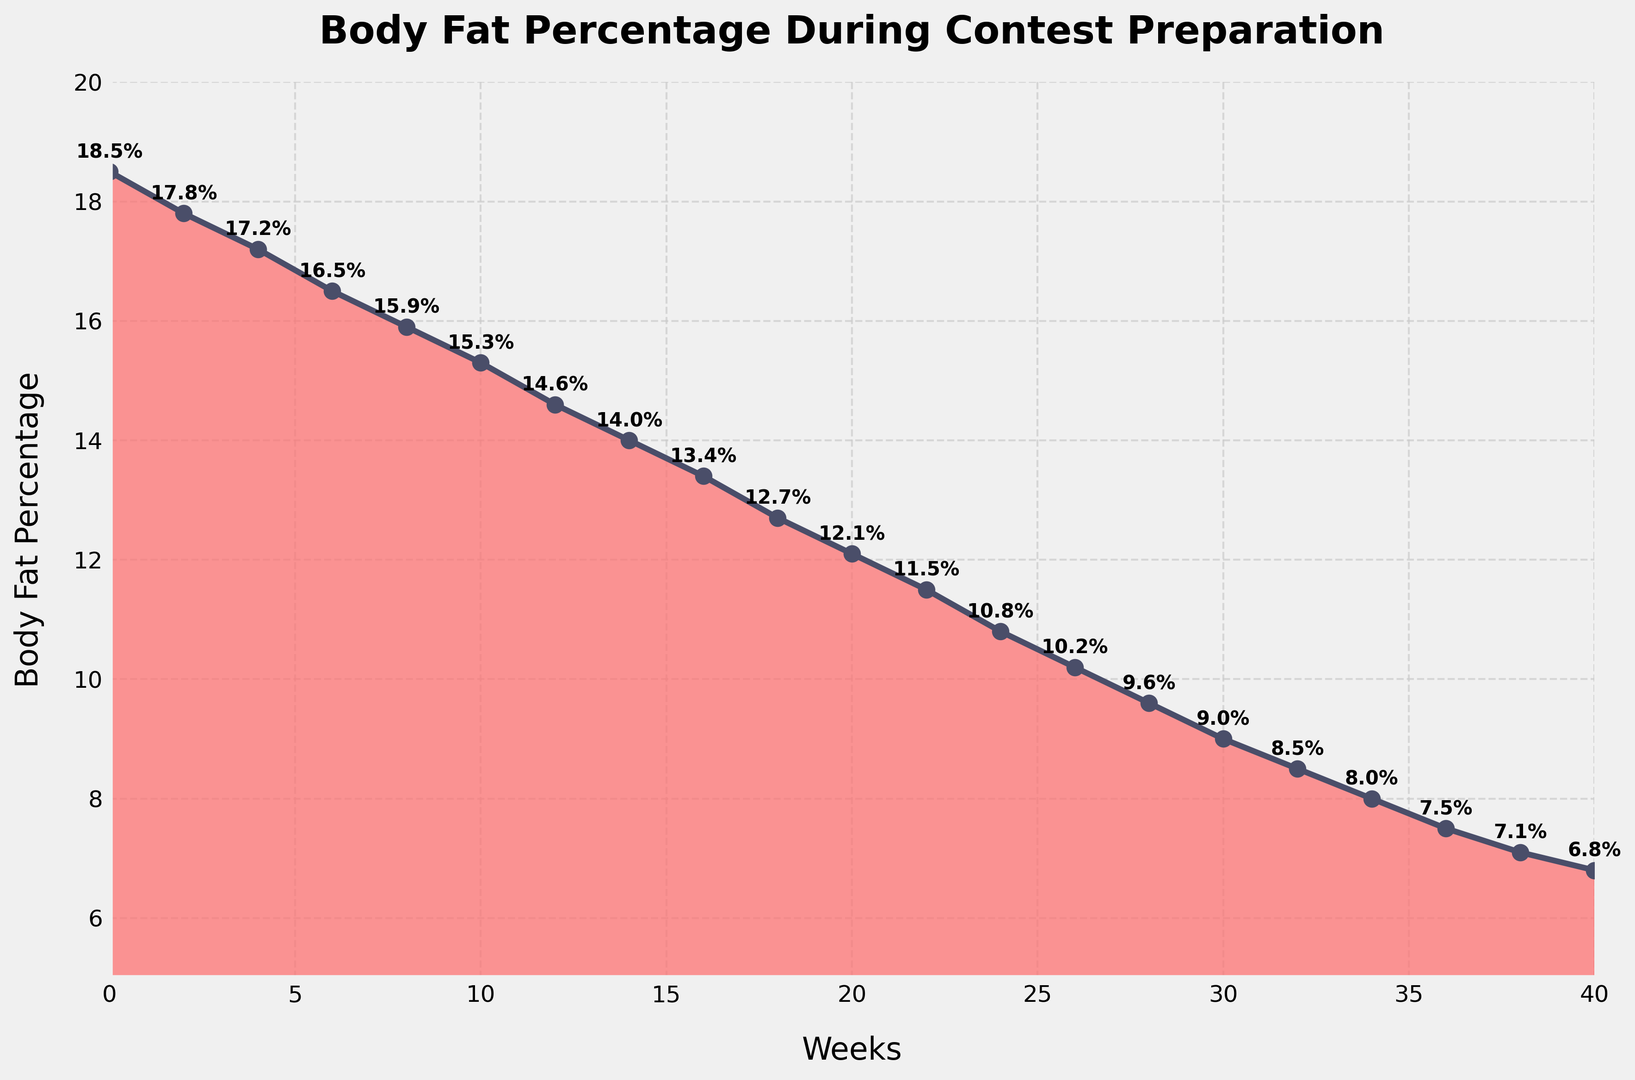What's the percentage decrease in body fat from week 0 to week 40? To find the percentage decrease, subtract the body fat percentage at week 40 from week 0 and then divide by the body fat percentage at week 0. Multiply by 100 for percentage. (18.5 - 6.8) / 18.5 * 100 = 63.24%
Answer: 63.24% During which week does the body fat percentage drop below 10% for the first time? Locate the point where the body fat percentage intersects 10% on the plot. It is seen that this occurs at week 26.
Answer: Week 26 How many weeks did it take for the body fat percentage to decrease from 15% to below 10%? Identify the weeks corresponding to 15% and 10% on the chart. The body fat percentage is 15% in week 10 and drops below 10% in week 26. The time taken is 26 - 10 = 16 weeks.
Answer: 16 weeks What is the average body fat percentage over the contest preparation period? Sum all the body fat percentage values provided and divide by the number of weeks (which is 21). (18.5 + 17.8 + 17.2 + 16.5 + 15.9 + 15.3 + 14.6 + 14.0 + 13.4 + 12.7 + 12.1 + 11.5 + 10.8 + 10.2 + 9.6 + 9.0 + 8.5 + 8.0 + 7.5 + 7.1 + 6.8)/21 = 12.81%
Answer: 12.81% What is the steepest drop in body fat percentage between two consecutive data points? Analyze the changes between each consecutive week. The greatest change occurs between week 0 to week 2: (18.5 - 17.8) = 0.7. Verify by comparing with other intervals - all other changes are smaller than 0.7.
Answer: 0.7% By how much does the body fat percentage change on average every 4 weeks? First, identify the body fat percentage at multiples of 4 weeks: Weeks = [0, 4, 8, 12, 16, 20, 24, 28, 32, 36, 40], Values = [18.5, 17.2, 15.9, 14.6, 13.4, 12.1, 10.8, 9.6, 8.5, 7.5, 6.8]. Calculate each 4-week change, then average: (1.3 + 1.3 + 1.3 + 1.2 + 1.3 + 1.3 + 1.2 + 1.1 + 1.0 + 0.7)/10 = 1.17%
Answer: 1.17% Does the rate of body fat reduction slow down towards the end of the preparation period? Examine the spacing between the data points from weeks 30 to 40. The rate of decrease in body fat percentage diminishes, from a more significant drop between earlier weeks to only a 0.7% drop from weeks 36 to 40.
Answer: Yes What is the body fat percentage at the midpoint of the contest preparation (week 20)? Locate week 20 on the x-axis and identify the corresponding y-value. The body fat percentage at week 20 is 12.1%.
Answer: 12.1% 